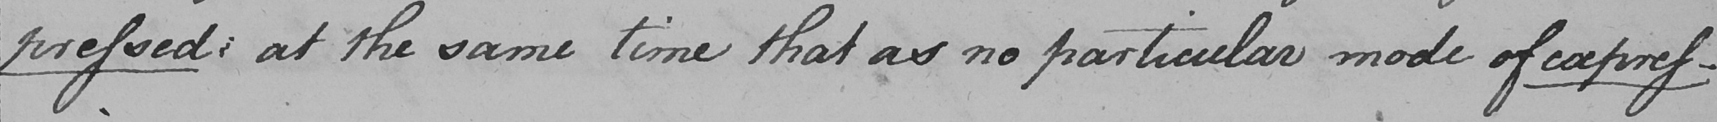Please transcribe the handwritten text in this image. pressed :  at the same time that as no particular mode of expres- 